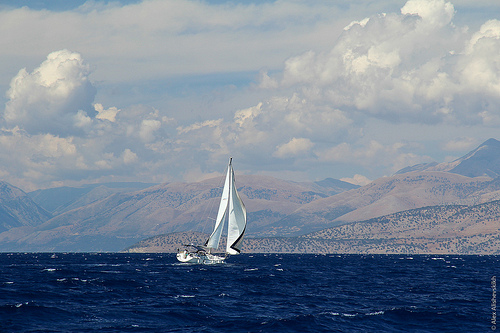What might be the weather conditions for sailing in this image? The weather conditions for sailing appear to be ideal. The sky is partly cloudy with plenty of sunlight, and the presence of an unfurled sail suggests that there is a strong and consistent wind, which is perfect for a sailboat. 